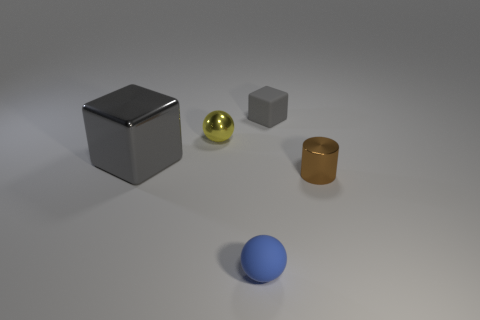How many gray blocks must be subtracted to get 1 gray blocks? 1 Add 4 small rubber objects. How many objects exist? 9 Subtract all cylinders. How many objects are left? 4 Subtract all brown metallic things. Subtract all blue matte cylinders. How many objects are left? 4 Add 5 tiny brown metallic cylinders. How many tiny brown metallic cylinders are left? 6 Add 4 green metal cylinders. How many green metal cylinders exist? 4 Subtract 0 cyan cubes. How many objects are left? 5 Subtract all cyan balls. Subtract all purple blocks. How many balls are left? 2 